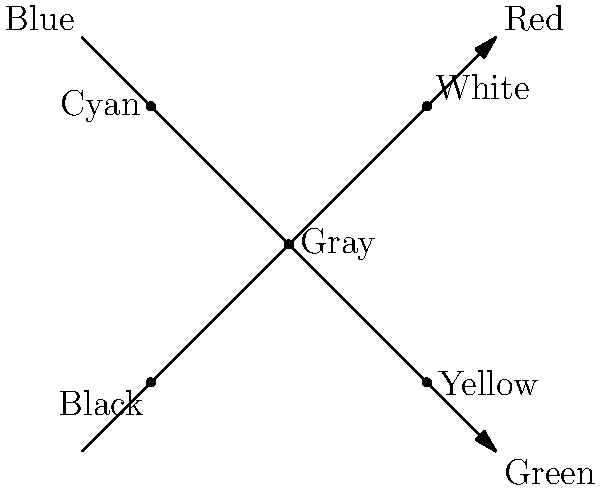In the RGB color space, mixing colors follows a group structure. Given the diagram showing the mixing of Red, Green, and Blue, which color represents the identity element of this group, and what property does it exhibit when combined with other colors? To answer this question, let's analyze the group structure of color mixing in RGB color space:

1. The RGB color space is represented by a 3D cube, where the axes correspond to Red, Green, and Blue intensities.

2. In the given 2D projection, we can see key points:
   - (0,0): Black (absence of all colors)
   - (2,2): White (maximum intensity of all colors)
   - (1,1): Gray (equal mix of all colors)

3. In group theory, an identity element is an element that, when combined with any other element, leaves that element unchanged.

4. Observing the diagram, we can see that Black (0,0) doesn't change other colors when mixed with them. It acts as an additive base.

5. However, in the context of light and color mixing, White (2,2) acts as the identity element. This is because:
   - Adding white light to any color doesn't change its hue, it only affects its saturation.
   - In terms of group operations, combining any color with white in RGB space results in the original color.

6. This property of white light aligns with the definition of an identity element in group theory: it leaves other elements unchanged when combined with them.

Therefore, White (2,2) represents the identity element in this color mixing group structure.
Answer: White; it leaves other colors unchanged when mixed. 